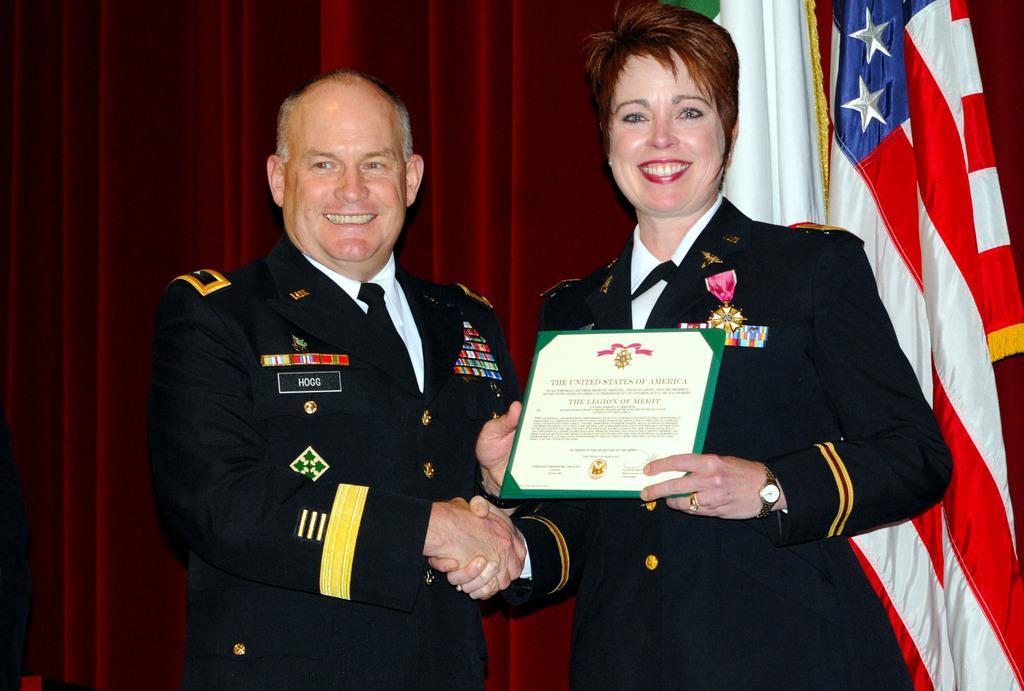What are the two people in the image doing? Two people are giving a handshake in the image. What is the facial expression of the people in the image? Both people are smiling. What is the woman holding in the image? The woman is holding a certificate. What can be seen in the background of the image? There is a red curtain and flags in the background. What type of dog can be seen sitting next to the book in the image? There is no dog or book present in the image. How are the people sorting the items in the image? The people are not sorting any items in the image; they are giving a handshake and holding a certificate. 